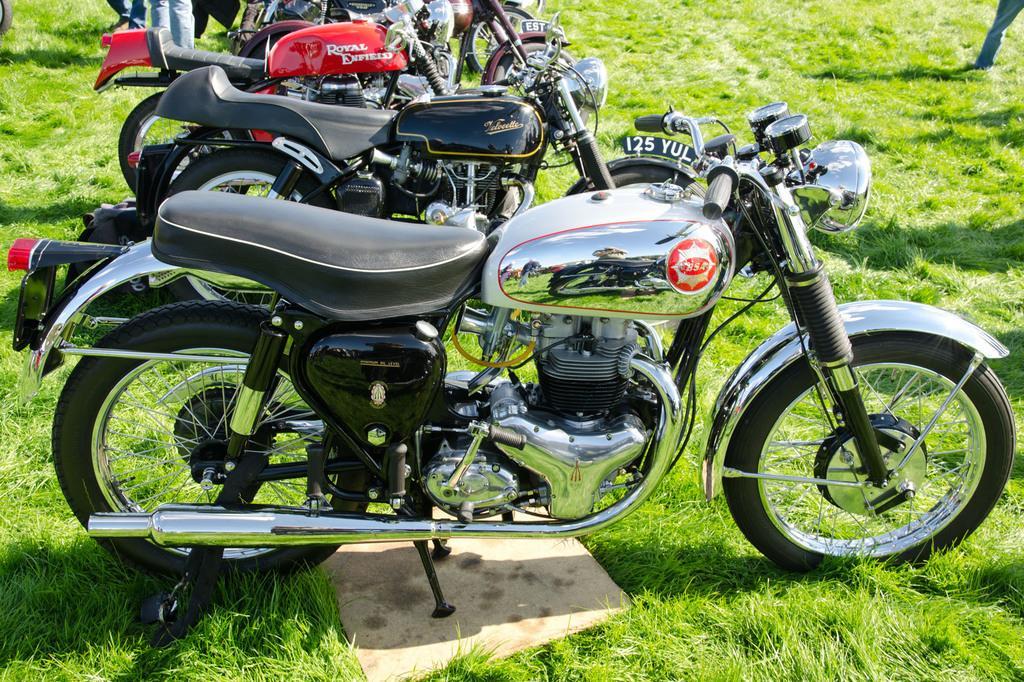Could you give a brief overview of what you see in this image? This image consists of few bikes which are on the glass. 